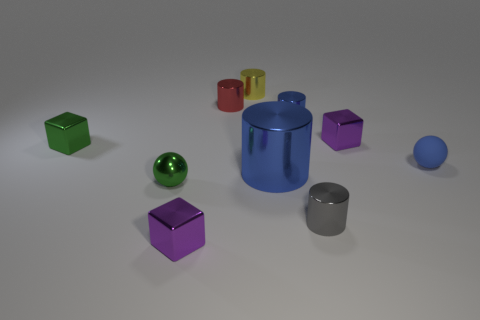What materials seem to be represented by the objects in the scene? The objects in the image appear to have a variety of textures that suggest different materials. The shinier surfaces on some blocks and the large blue cylinder imply a metallic quality, whereas the green and blue spheres, due to their reflections and sheen, seem to be made of rubber. Furthermore, the matte finish on the red cylinder could indicate a plastic material. These varying textures contribute to the depth and visual interest of the scene. 